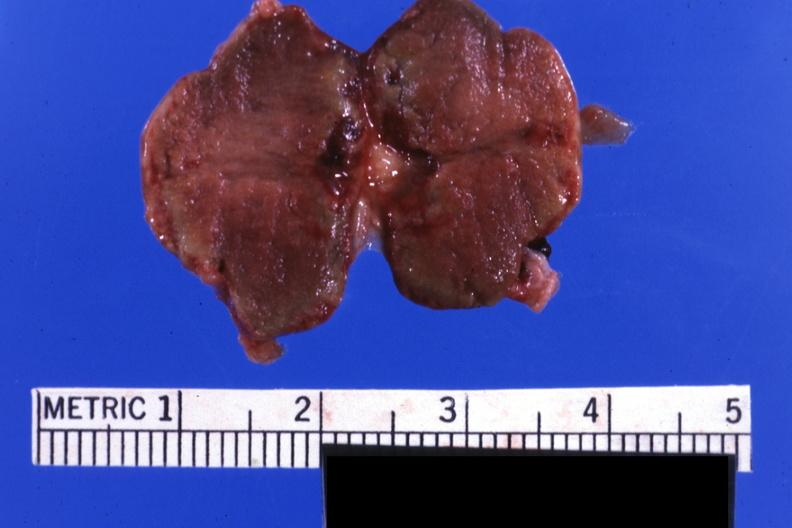s retroperitoneal liposarcoma present?
Answer the question using a single word or phrase. No 